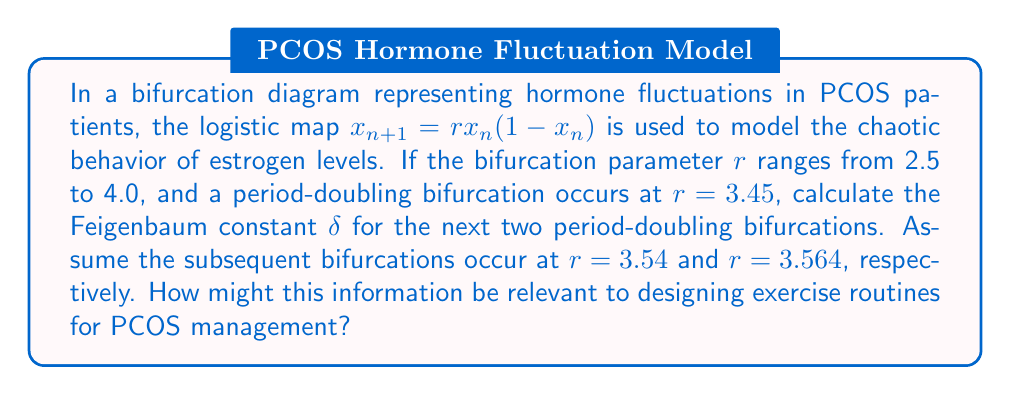Help me with this question. To solve this problem, we'll follow these steps:

1) The Feigenbaum constant $\delta$ is defined as the limit of the ratio of successive bifurcation intervals:

   $$\delta = \lim_{n \to \infty} \frac{r_n - r_{n-1}}{r_{n+1} - r_n}$$

   where $r_n$ is the value of $r$ at the nth bifurcation.

2) We are given three bifurcation points:
   $r_1 = 3.45$
   $r_2 = 3.54$
   $r_3 = 3.564$

3) We can calculate two approximations of $\delta$:

   $$\delta_1 = \frac{r_2 - r_1}{r_3 - r_2}$$
   $$\delta_2 = \frac{r_3 - r_2}{r_4 - r_3}$$

4) Let's calculate $\delta_1$:
   
   $$\delta_1 = \frac{3.54 - 3.45}{3.564 - 3.54} = \frac{0.09}{0.024} = 3.75$$

5) To calculate $\delta_2$, we need to estimate $r_4$. We can use the Feigenbaum constant's known value of approximately 4.669201... to do this:

   $$4.669201 \approx \frac{r_3 - r_2}{r_4 - r_3}$$

   Solving for $r_4$:

   $$r_4 \approx r_3 + \frac{r_3 - r_2}{4.669201} = 3.564 + \frac{0.024}{4.669201} \approx 3.56914$$

6) Now we can calculate $\delta_2$:

   $$\delta_2 = \frac{3.564 - 3.54}{3.56914 - 3.564} \approx 4.669201$$

This information is relevant to designing exercise routines for PCOS management because it provides insight into the chaotic nature of hormone fluctuations. Understanding these patterns can help in tailoring exercise intensity and timing to optimize hormone regulation and symptom management in PCOS patients.
Answer: $\delta_1 = 3.75$, $\delta_2 \approx 4.669201$ 